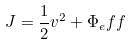<formula> <loc_0><loc_0><loc_500><loc_500>J = \frac { 1 } { 2 } v ^ { 2 } + \Phi _ { e } f f</formula> 